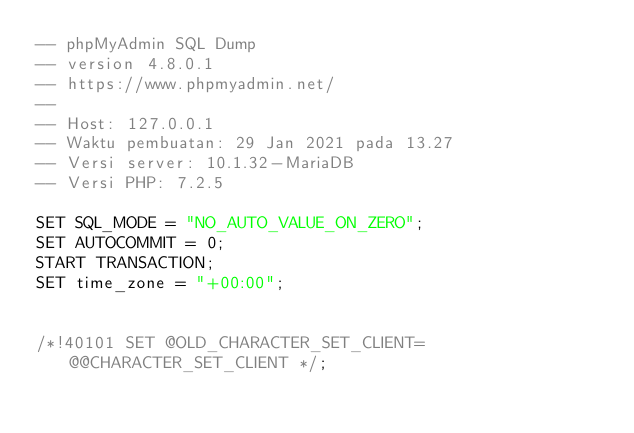Convert code to text. <code><loc_0><loc_0><loc_500><loc_500><_SQL_>-- phpMyAdmin SQL Dump
-- version 4.8.0.1
-- https://www.phpmyadmin.net/
--
-- Host: 127.0.0.1
-- Waktu pembuatan: 29 Jan 2021 pada 13.27
-- Versi server: 10.1.32-MariaDB
-- Versi PHP: 7.2.5

SET SQL_MODE = "NO_AUTO_VALUE_ON_ZERO";
SET AUTOCOMMIT = 0;
START TRANSACTION;
SET time_zone = "+00:00";


/*!40101 SET @OLD_CHARACTER_SET_CLIENT=@@CHARACTER_SET_CLIENT */;</code> 